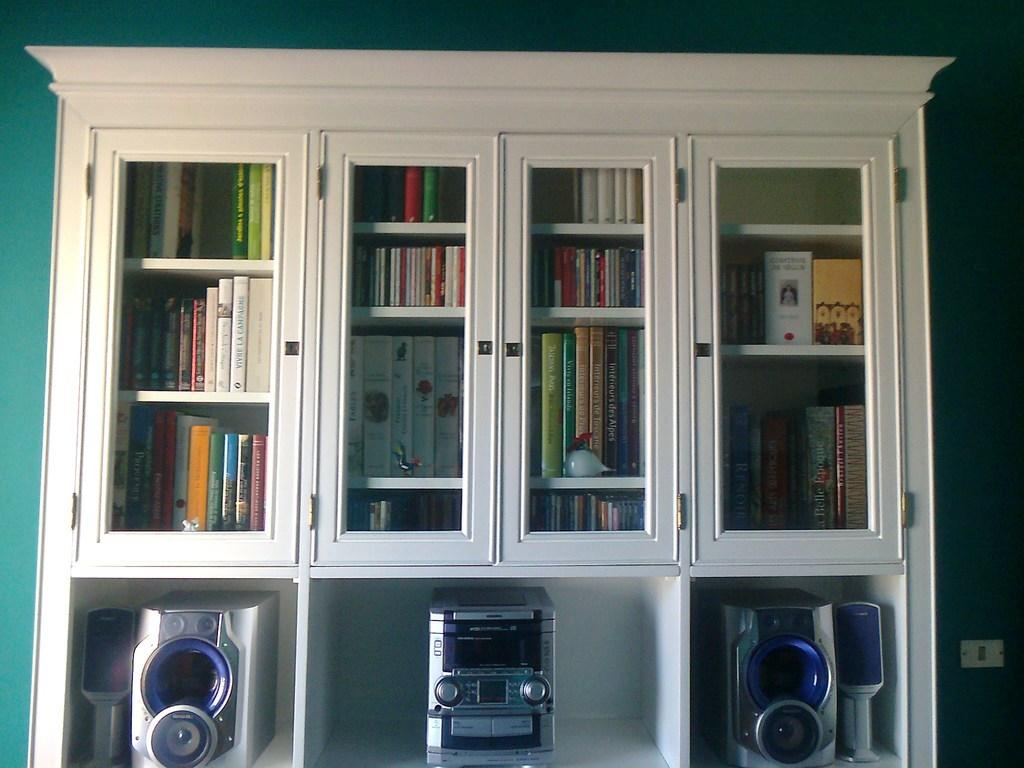<image>
Provide a brief description of the given image. A white book shelf is full of books such as Vive le Champagne and a stereo set at the lower part of the shelf. 